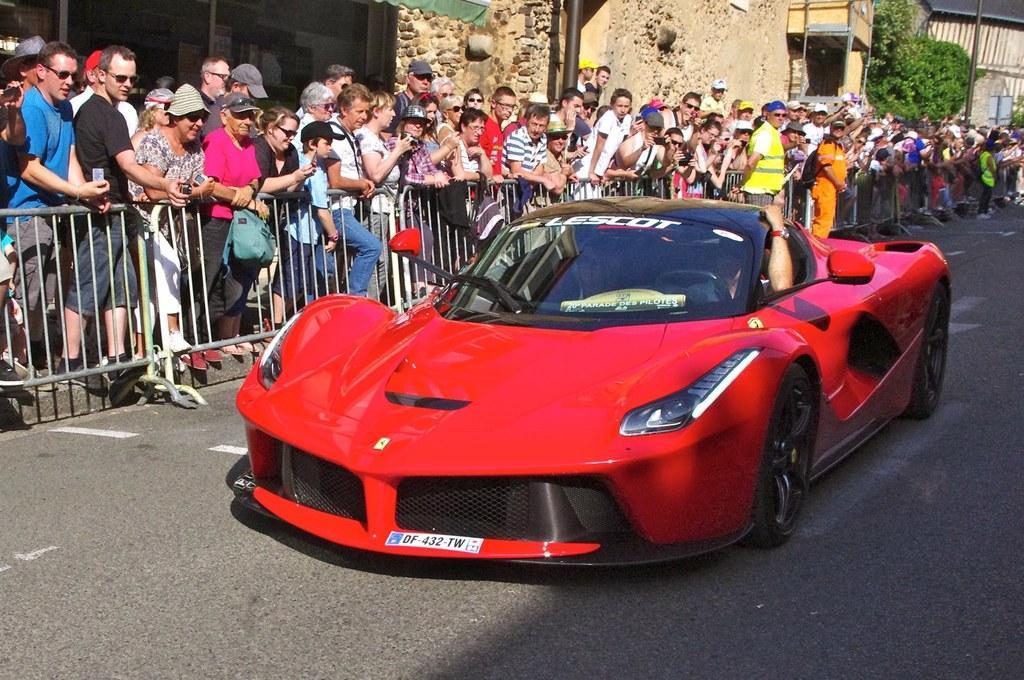In one or two sentences, can you explain what this image depicts? In this image I can see the car and the car is in red color and I can see few people sitting in the car. In the background I can see the railing, few people standing and I can also see few trees in green color and the building is in cream color. 